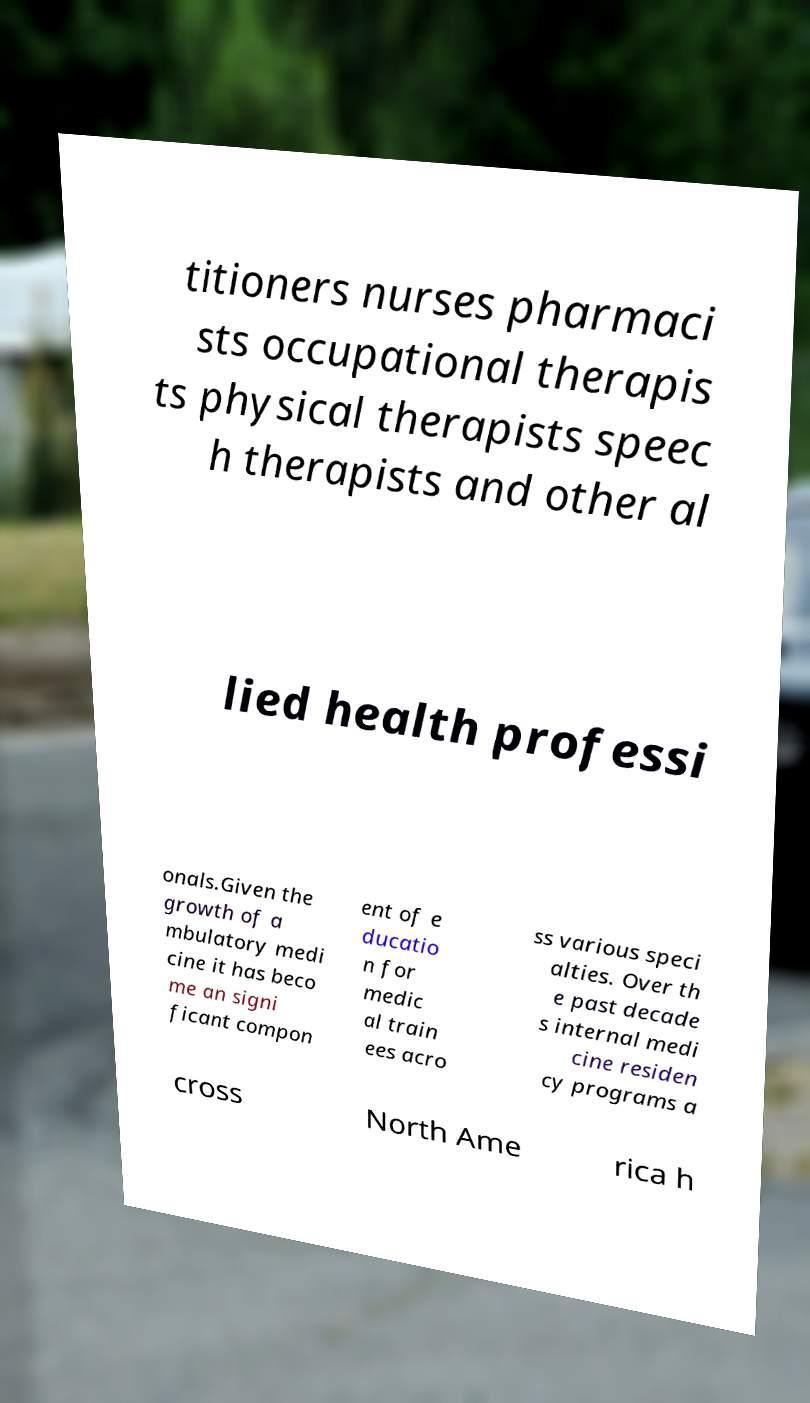Can you read and provide the text displayed in the image?This photo seems to have some interesting text. Can you extract and type it out for me? titioners nurses pharmaci sts occupational therapis ts physical therapists speec h therapists and other al lied health professi onals.Given the growth of a mbulatory medi cine it has beco me an signi ficant compon ent of e ducatio n for medic al train ees acro ss various speci alties. Over th e past decade s internal medi cine residen cy programs a cross North Ame rica h 